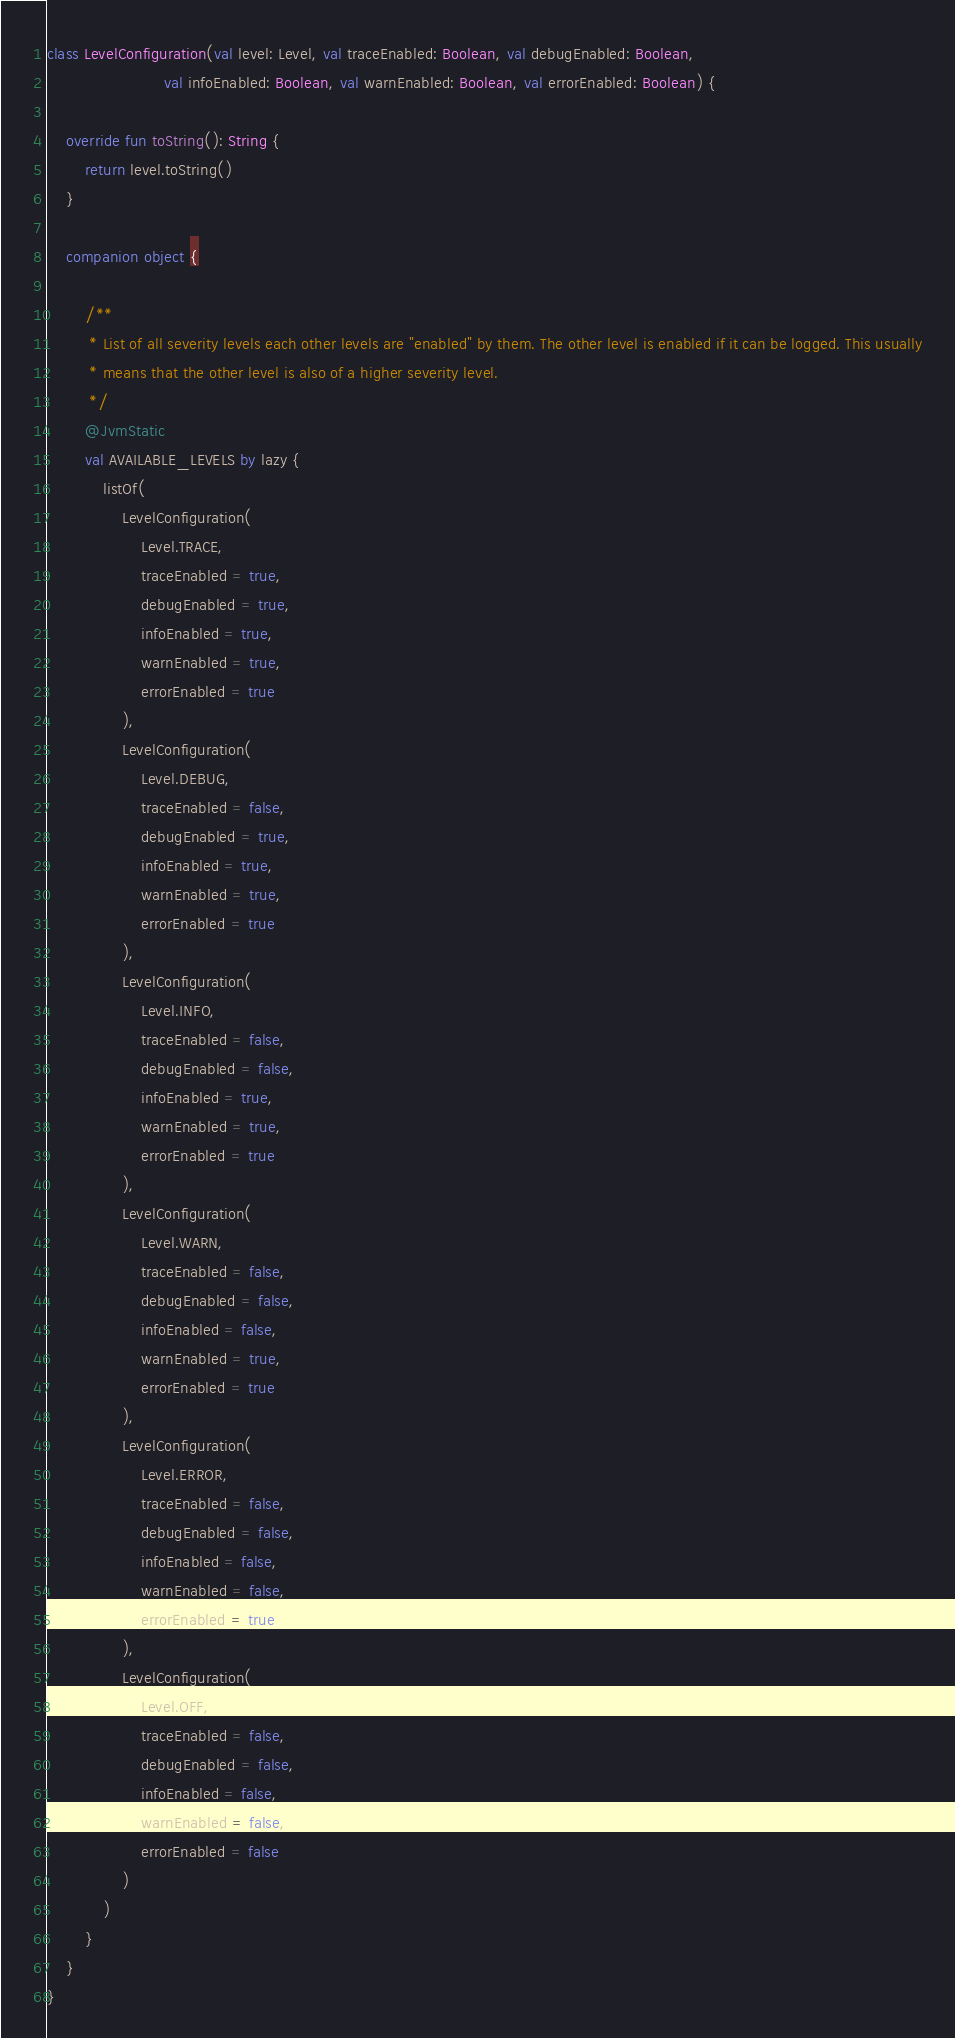Convert code to text. <code><loc_0><loc_0><loc_500><loc_500><_Kotlin_>class LevelConfiguration(val level: Level, val traceEnabled: Boolean, val debugEnabled: Boolean,
                         val infoEnabled: Boolean, val warnEnabled: Boolean, val errorEnabled: Boolean) {

    override fun toString(): String {
        return level.toString()
    }

    companion object {

        /**
         * List of all severity levels each other levels are "enabled" by them. The other level is enabled if it can be logged. This usually
         * means that the other level is also of a higher severity level.
         */
        @JvmStatic
        val AVAILABLE_LEVELS by lazy {
            listOf(
                LevelConfiguration(
                    Level.TRACE,
                    traceEnabled = true,
                    debugEnabled = true,
                    infoEnabled = true,
                    warnEnabled = true,
                    errorEnabled = true
                ),
                LevelConfiguration(
                    Level.DEBUG,
                    traceEnabled = false,
                    debugEnabled = true,
                    infoEnabled = true,
                    warnEnabled = true,
                    errorEnabled = true
                ),
                LevelConfiguration(
                    Level.INFO,
                    traceEnabled = false,
                    debugEnabled = false,
                    infoEnabled = true,
                    warnEnabled = true,
                    errorEnabled = true
                ),
                LevelConfiguration(
                    Level.WARN,
                    traceEnabled = false,
                    debugEnabled = false,
                    infoEnabled = false,
                    warnEnabled = true,
                    errorEnabled = true
                ),
                LevelConfiguration(
                    Level.ERROR,
                    traceEnabled = false,
                    debugEnabled = false,
                    infoEnabled = false,
                    warnEnabled = false,
                    errorEnabled = true
                ),
                LevelConfiguration(
                    Level.OFF,
                    traceEnabled = false,
                    debugEnabled = false,
                    infoEnabled = false,
                    warnEnabled = false,
                    errorEnabled = false
                )
            )
        }
    }
}
</code> 